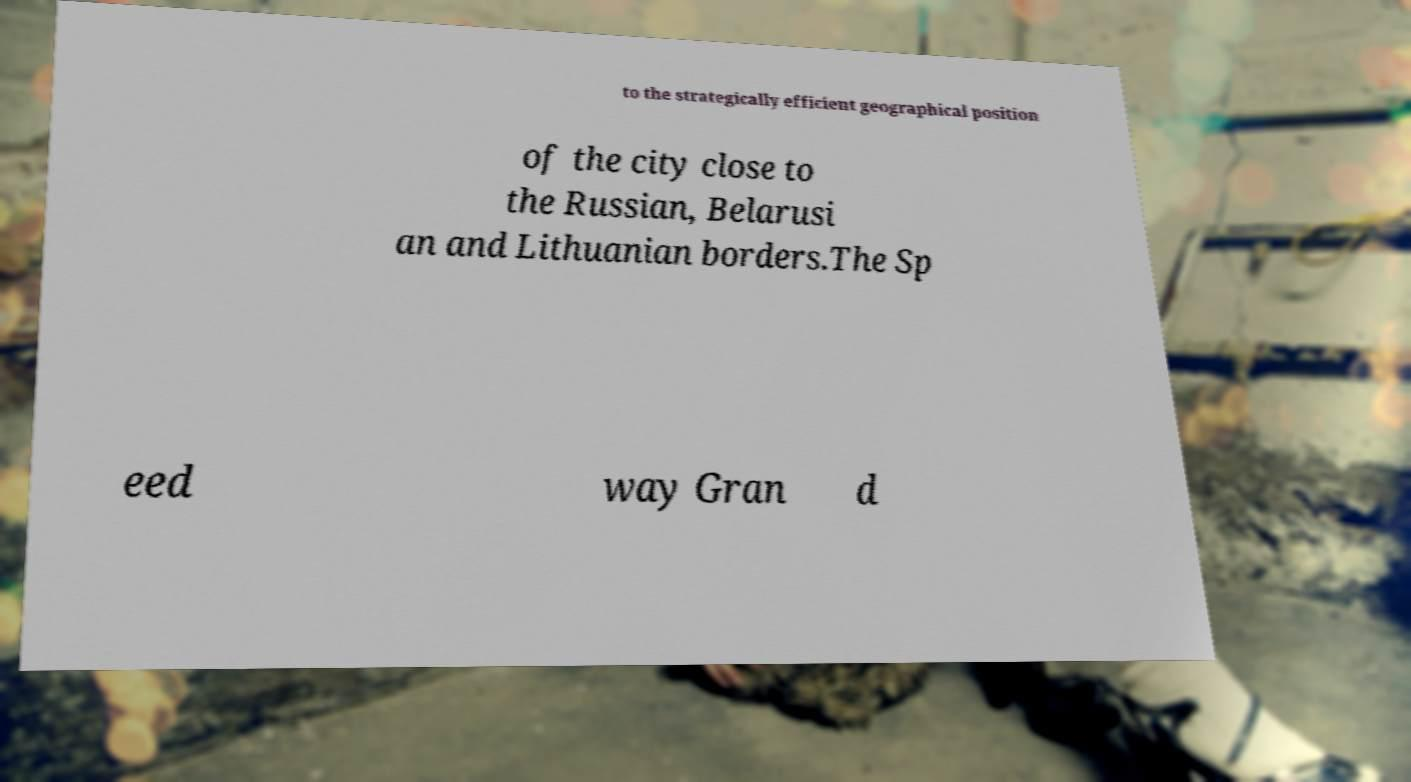Could you assist in decoding the text presented in this image and type it out clearly? to the strategically efficient geographical position of the city close to the Russian, Belarusi an and Lithuanian borders.The Sp eed way Gran d 